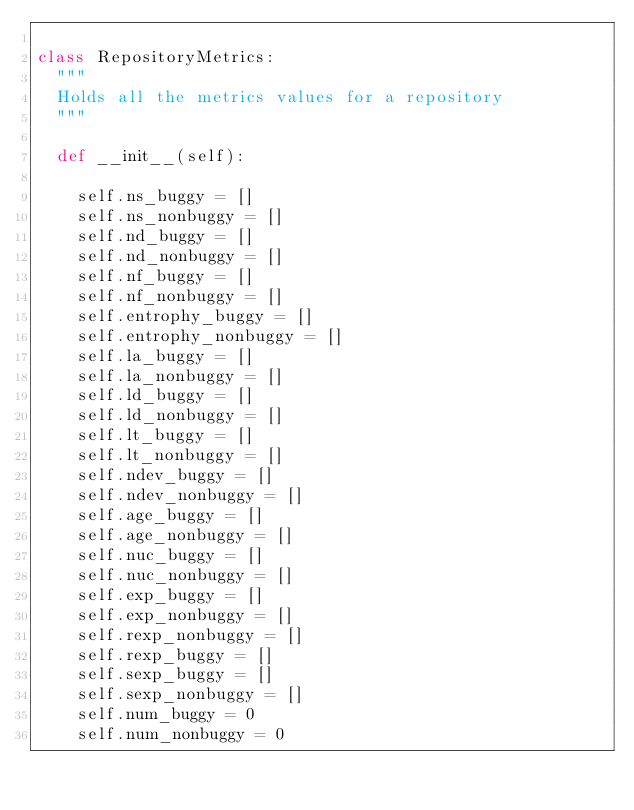<code> <loc_0><loc_0><loc_500><loc_500><_Python_>
class RepositoryMetrics:
  """
  Holds all the metrics values for a repository
  """

  def __init__(self):

    self.ns_buggy = []
    self.ns_nonbuggy = []
    self.nd_buggy = []
    self.nd_nonbuggy = []
    self.nf_buggy = []
    self.nf_nonbuggy = []
    self.entrophy_buggy = []
    self.entrophy_nonbuggy = []
    self.la_buggy = []
    self.la_nonbuggy = []
    self.ld_buggy = []
    self.ld_nonbuggy = []
    self.lt_buggy = []
    self.lt_nonbuggy = []
    self.ndev_buggy = []
    self.ndev_nonbuggy = []
    self.age_buggy = []
    self.age_nonbuggy = []
    self.nuc_buggy = []
    self.nuc_nonbuggy = []
    self.exp_buggy = []
    self.exp_nonbuggy = []
    self.rexp_nonbuggy = []
    self.rexp_buggy = []
    self.sexp_buggy = []
    self.sexp_nonbuggy = []
    self.num_buggy = 0
    self.num_nonbuggy = 0
</code> 